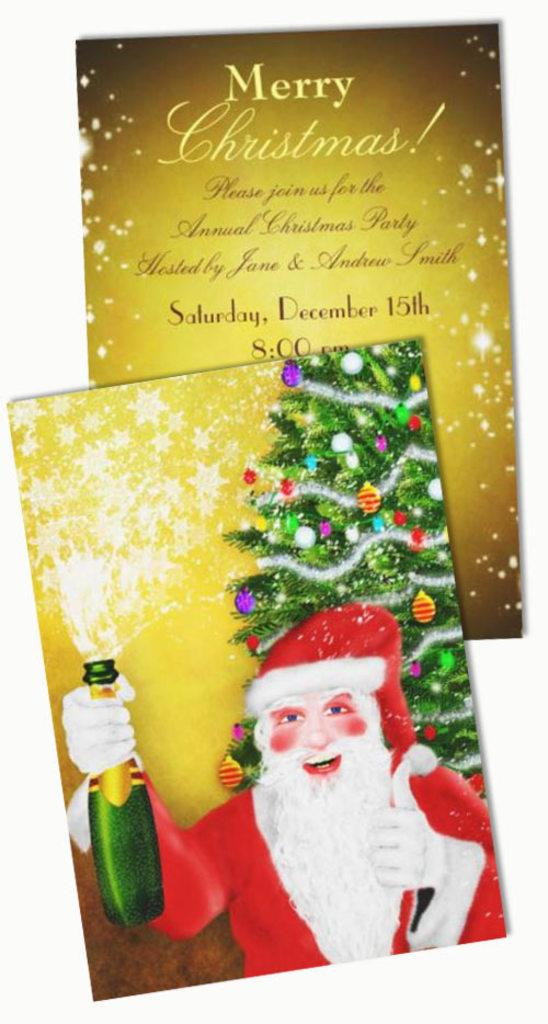What type of items are present in the image? There are greeting cards in the image. Can you describe the text on one of the greeting cards? One greeting card has text on it. What is depicted on the other greeting card? The other greeting card has an image of Santa Claus holding a bottle. What is visible in the background of the Santa Claus image? There is a Christmas tree in the background of the Santa Claus image. What type of wire is holding the bat in the image? There is no wire or bat present in the image; it features greeting cards with text and an image of Santa Claus holding a bottle. How many stars can be seen in the image? There are no stars visible in the image. 